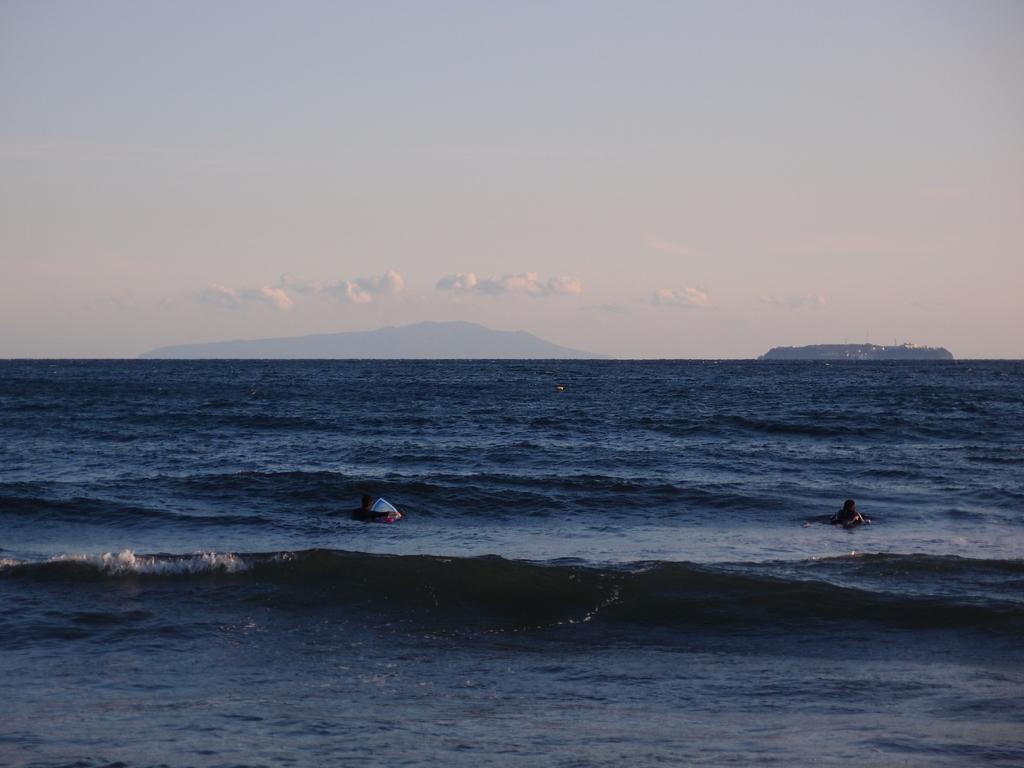Please provide a concise description of this image. In this image I can see people in the water. In the background I can see the sky. 